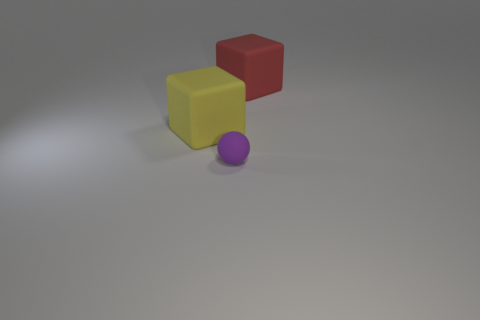There is a red rubber object; does it have the same shape as the large rubber object to the left of the tiny matte ball?
Your response must be concise. Yes. There is a rubber object that is behind the large yellow cube; is its shape the same as the yellow object?
Provide a short and direct response. Yes. What number of things are either rubber things that are on the right side of the purple thing or large matte things behind the big yellow object?
Provide a short and direct response. 1. Is the number of tiny purple rubber balls less than the number of large cubes?
Give a very brief answer. Yes. What number of things are purple balls or large purple balls?
Give a very brief answer. 1. Is the shape of the yellow matte thing the same as the red object?
Ensure brevity in your answer.  Yes. Is the size of the rubber block to the left of the big red thing the same as the matte cube right of the purple rubber sphere?
Your answer should be compact. Yes. Are there any other things that have the same color as the ball?
Offer a terse response. No. Are there fewer tiny purple matte objects on the right side of the sphere than large purple matte blocks?
Make the answer very short. No. Are there more brown matte things than large rubber things?
Offer a terse response. No. 